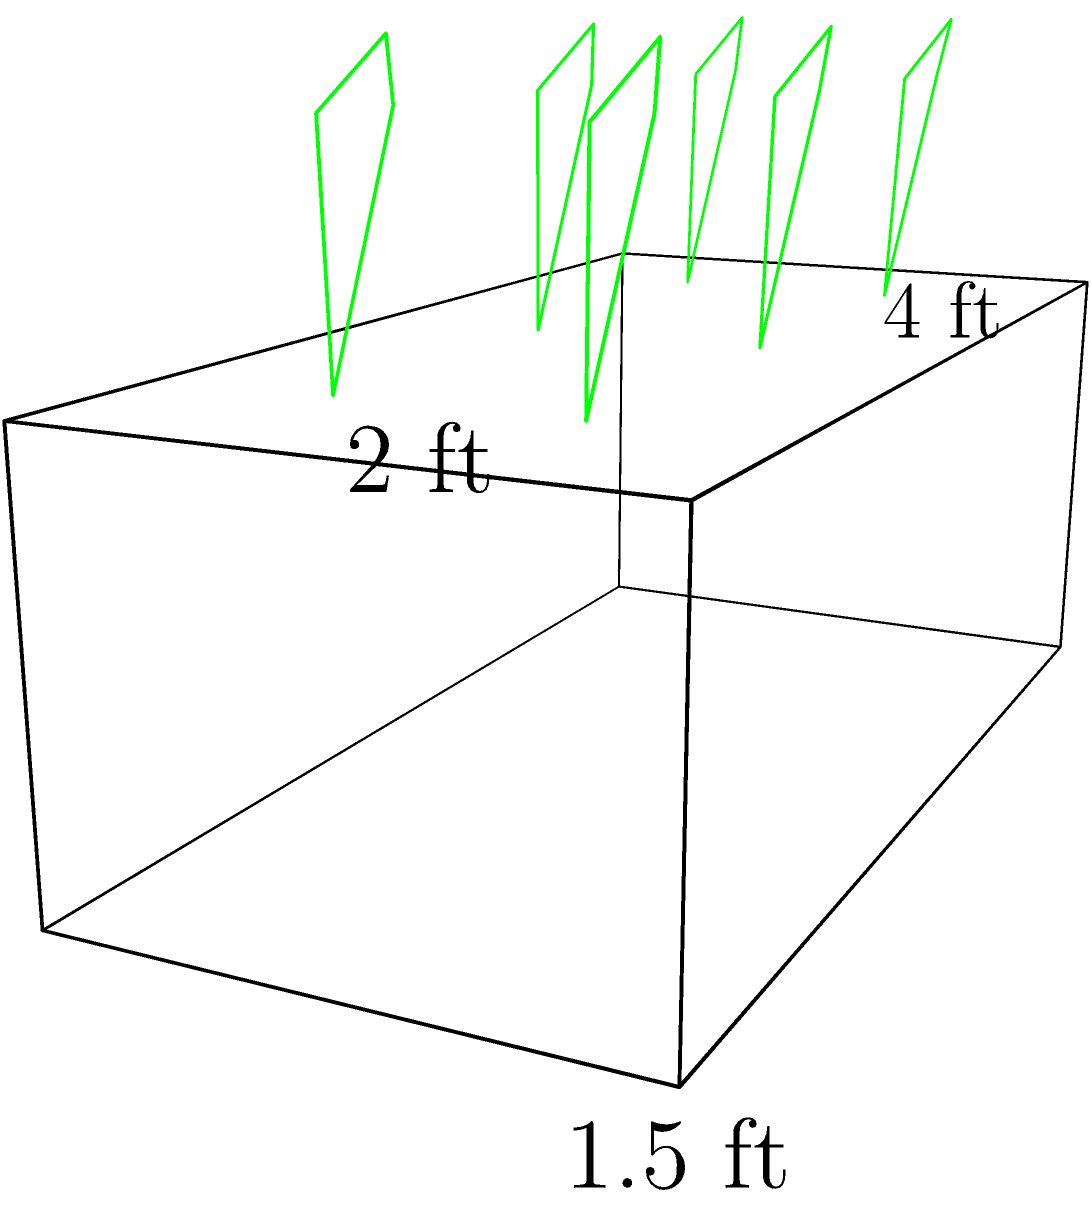As part of your eco-friendly landscaping project on Eucalyptus Street, you're planning to build a rectangular prism-shaped planter box for native plants. The box measures 4 feet in length, 2 feet in width, and 1.5 feet in height. How many cubic feet of soil will be needed to fill this planter box? To calculate the volume of the rectangular prism-shaped planter box, we need to use the formula:

$$V = l \times w \times h$$

Where:
$V$ = volume
$l$ = length
$w$ = width
$h$ = height

Given dimensions:
Length ($l$) = 4 feet
Width ($w$) = 2 feet
Height ($h$) = 1.5 feet

Let's substitute these values into the formula:

$$V = 4 \text{ ft} \times 2 \text{ ft} \times 1.5 \text{ ft}$$

Now, let's perform the multiplication:

$$V = 12 \text{ cubic feet}$$

Therefore, the planter box will require 12 cubic feet of soil to be filled completely.
Answer: 12 cubic feet 